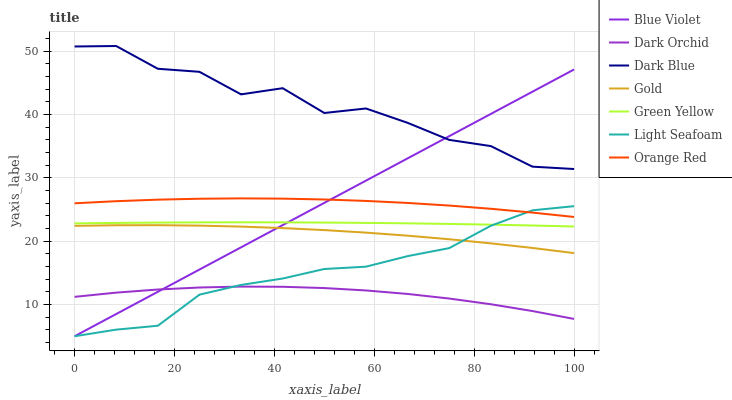Does Dark Orchid have the minimum area under the curve?
Answer yes or no. Yes. Does Dark Blue have the maximum area under the curve?
Answer yes or no. Yes. Does Gold have the minimum area under the curve?
Answer yes or no. No. Does Gold have the maximum area under the curve?
Answer yes or no. No. Is Blue Violet the smoothest?
Answer yes or no. Yes. Is Dark Blue the roughest?
Answer yes or no. Yes. Is Gold the smoothest?
Answer yes or no. No. Is Gold the roughest?
Answer yes or no. No. Does Light Seafoam have the lowest value?
Answer yes or no. Yes. Does Gold have the lowest value?
Answer yes or no. No. Does Dark Blue have the highest value?
Answer yes or no. Yes. Does Gold have the highest value?
Answer yes or no. No. Is Gold less than Dark Blue?
Answer yes or no. Yes. Is Dark Blue greater than Gold?
Answer yes or no. Yes. Does Blue Violet intersect Dark Orchid?
Answer yes or no. Yes. Is Blue Violet less than Dark Orchid?
Answer yes or no. No. Is Blue Violet greater than Dark Orchid?
Answer yes or no. No. Does Gold intersect Dark Blue?
Answer yes or no. No. 